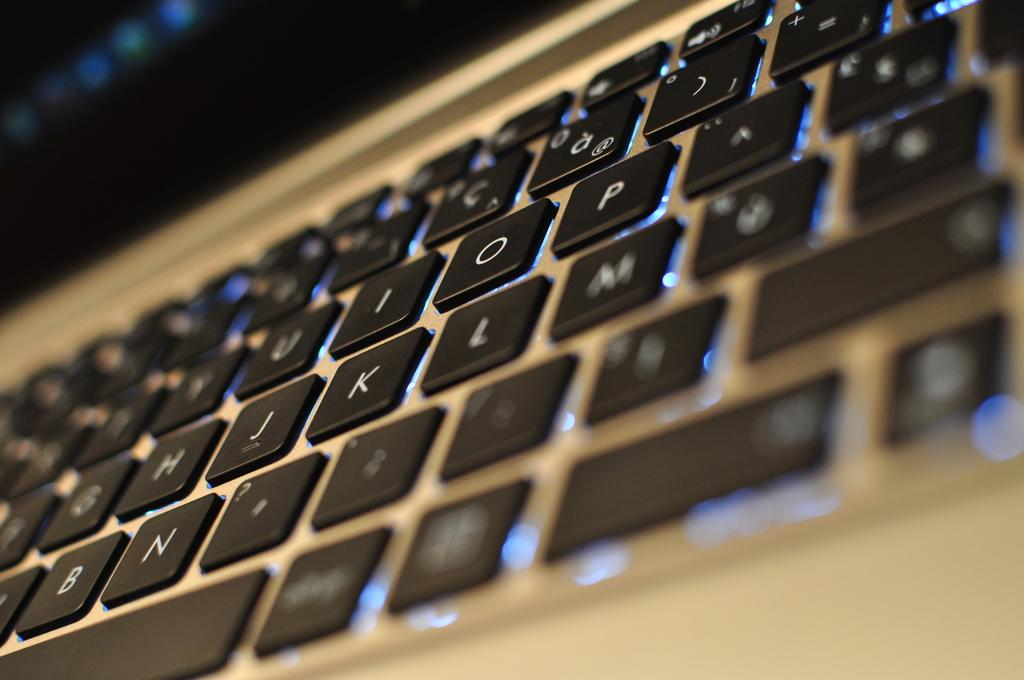<image>
Present a compact description of the photo's key features. a backlit keyboard with the letter m sort of blurred out 